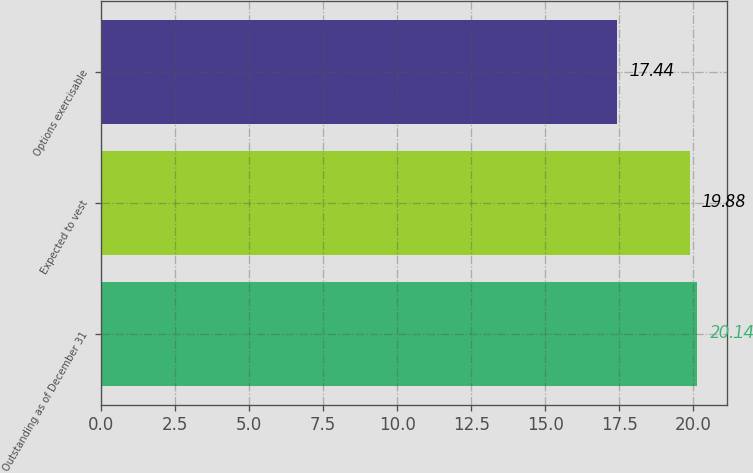<chart> <loc_0><loc_0><loc_500><loc_500><bar_chart><fcel>Outstanding as of December 31<fcel>Expected to vest<fcel>Options exercisable<nl><fcel>20.14<fcel>19.88<fcel>17.44<nl></chart> 